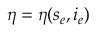Convert formula to latex. <formula><loc_0><loc_0><loc_500><loc_500>\eta = \eta ( s _ { e } , i _ { e } )</formula> 